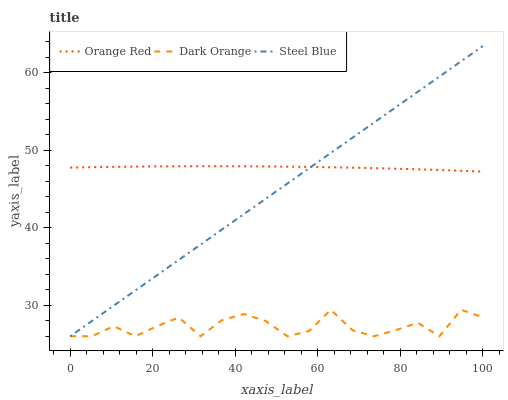Does Dark Orange have the minimum area under the curve?
Answer yes or no. Yes. Does Orange Red have the maximum area under the curve?
Answer yes or no. Yes. Does Steel Blue have the minimum area under the curve?
Answer yes or no. No. Does Steel Blue have the maximum area under the curve?
Answer yes or no. No. Is Steel Blue the smoothest?
Answer yes or no. Yes. Is Dark Orange the roughest?
Answer yes or no. Yes. Is Orange Red the smoothest?
Answer yes or no. No. Is Orange Red the roughest?
Answer yes or no. No. Does Dark Orange have the lowest value?
Answer yes or no. Yes. Does Orange Red have the lowest value?
Answer yes or no. No. Does Steel Blue have the highest value?
Answer yes or no. Yes. Does Orange Red have the highest value?
Answer yes or no. No. Is Dark Orange less than Orange Red?
Answer yes or no. Yes. Is Orange Red greater than Dark Orange?
Answer yes or no. Yes. Does Steel Blue intersect Dark Orange?
Answer yes or no. Yes. Is Steel Blue less than Dark Orange?
Answer yes or no. No. Is Steel Blue greater than Dark Orange?
Answer yes or no. No. Does Dark Orange intersect Orange Red?
Answer yes or no. No. 